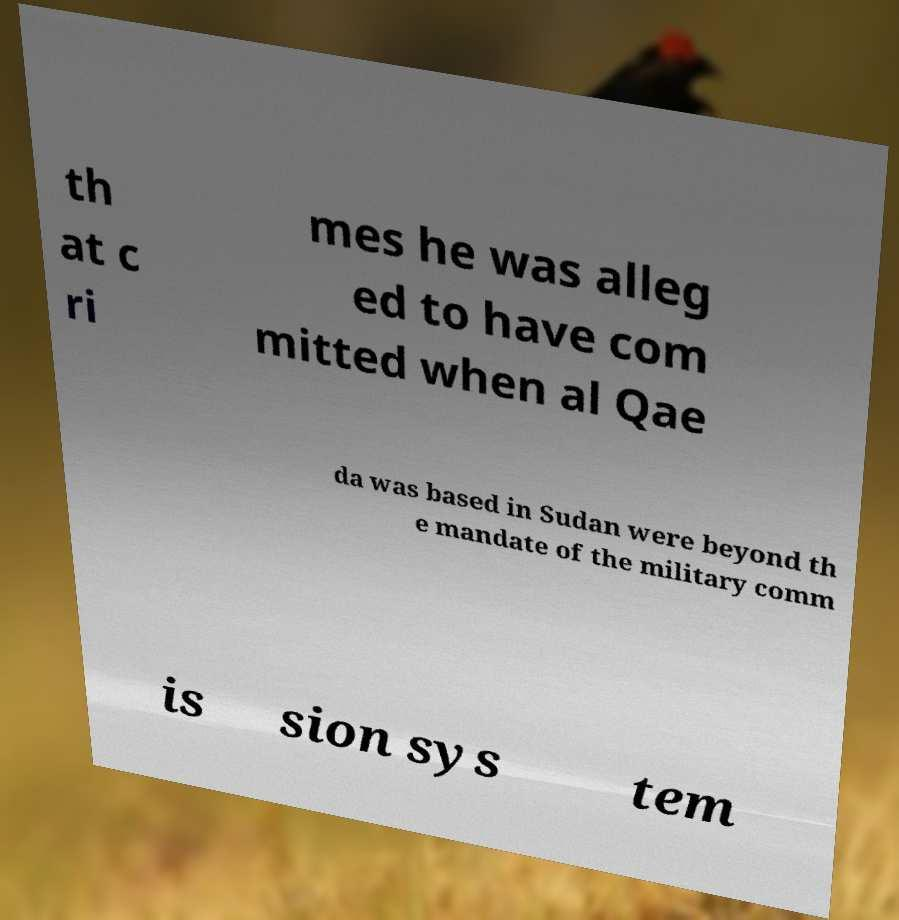There's text embedded in this image that I need extracted. Can you transcribe it verbatim? th at c ri mes he was alleg ed to have com mitted when al Qae da was based in Sudan were beyond th e mandate of the military comm is sion sys tem 